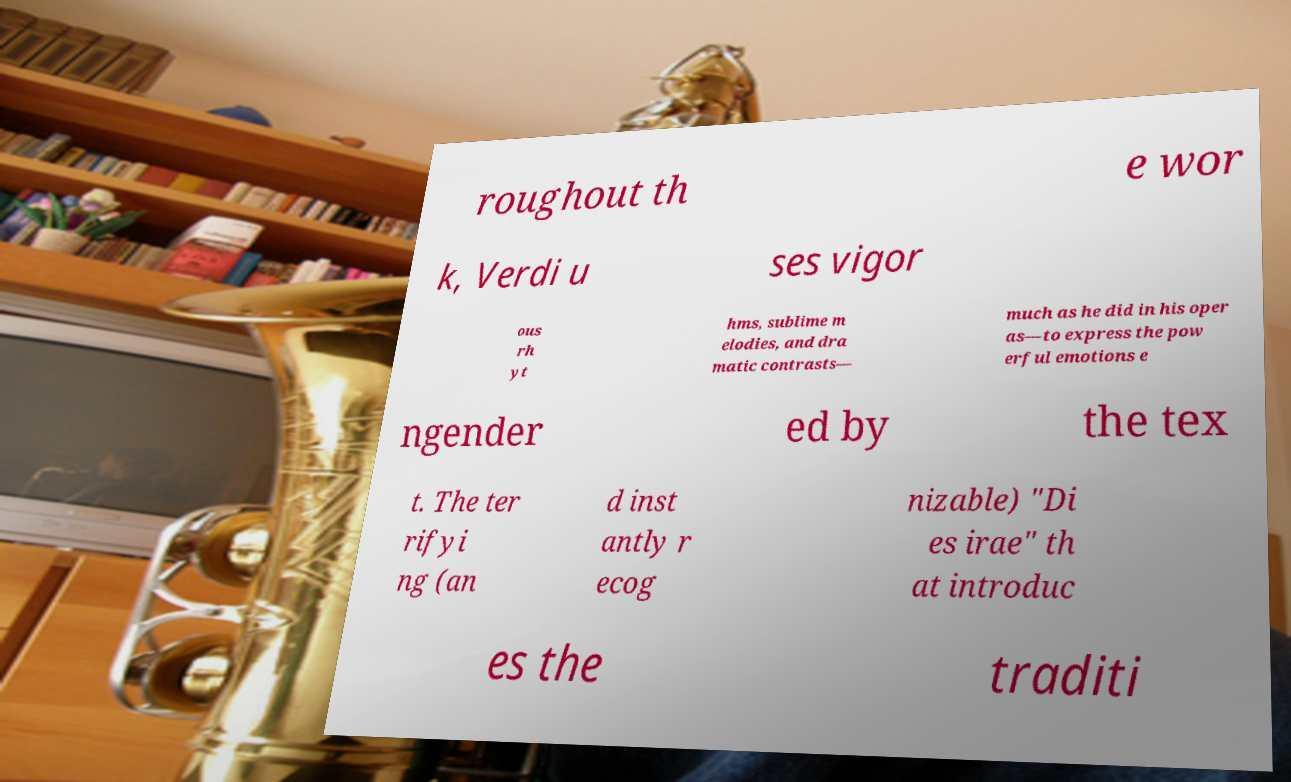Could you assist in decoding the text presented in this image and type it out clearly? roughout th e wor k, Verdi u ses vigor ous rh yt hms, sublime m elodies, and dra matic contrasts— much as he did in his oper as—to express the pow erful emotions e ngender ed by the tex t. The ter rifyi ng (an d inst antly r ecog nizable) "Di es irae" th at introduc es the traditi 